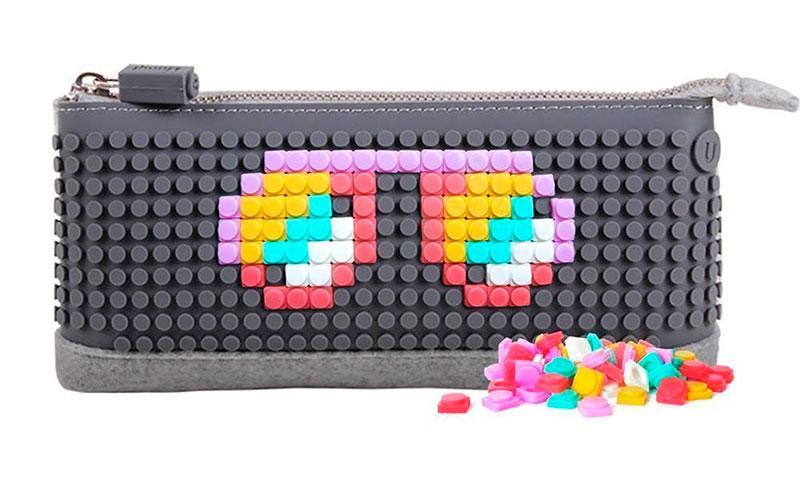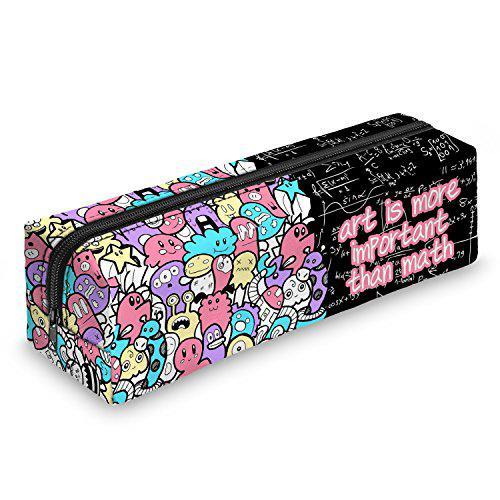The first image is the image on the left, the second image is the image on the right. For the images displayed, is the sentence "a pencil pouch has a zipper that is longer than the pouch" factually correct? Answer yes or no. Yes. 